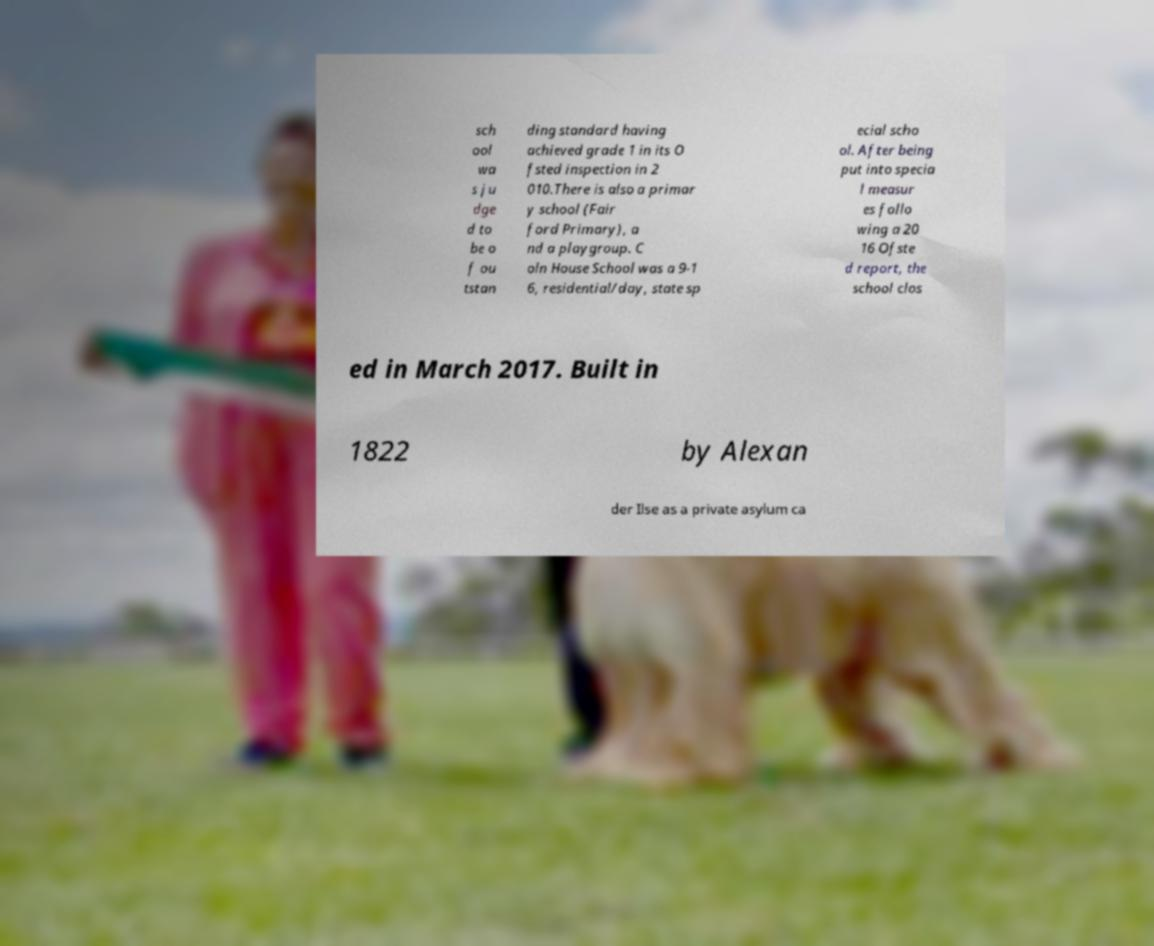Please identify and transcribe the text found in this image. sch ool wa s ju dge d to be o f ou tstan ding standard having achieved grade 1 in its O fsted inspection in 2 010.There is also a primar y school (Fair ford Primary), a nd a playgroup. C oln House School was a 9-1 6, residential/day, state sp ecial scho ol. After being put into specia l measur es follo wing a 20 16 Ofste d report, the school clos ed in March 2017. Built in 1822 by Alexan der Ilse as a private asylum ca 